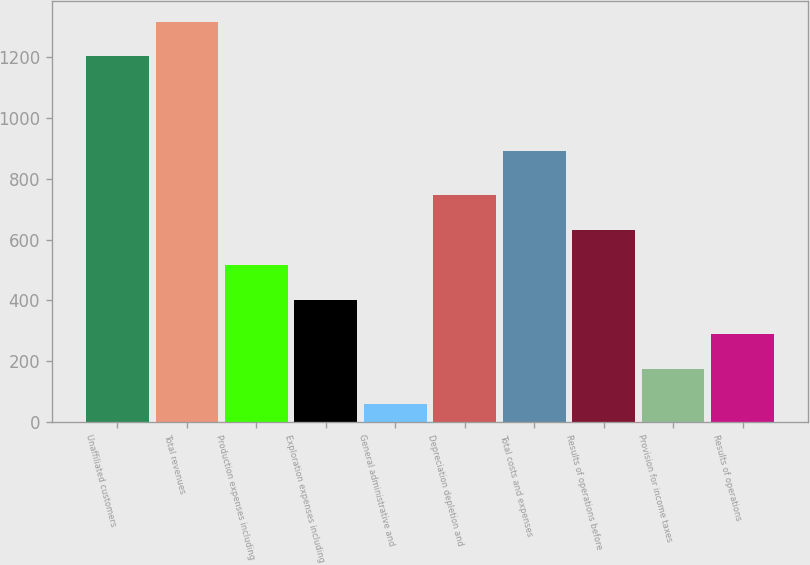Convert chart to OTSL. <chart><loc_0><loc_0><loc_500><loc_500><bar_chart><fcel>Unaffiliated customers<fcel>Total revenues<fcel>Production expenses including<fcel>Exploration expenses including<fcel>General administrative and<fcel>Depreciation depletion and<fcel>Total costs and expenses<fcel>Results of operations before<fcel>Provision for income taxes<fcel>Results of operations<nl><fcel>1204<fcel>1318.6<fcel>516.4<fcel>401.8<fcel>58<fcel>745.6<fcel>892<fcel>631<fcel>172.6<fcel>287.2<nl></chart> 